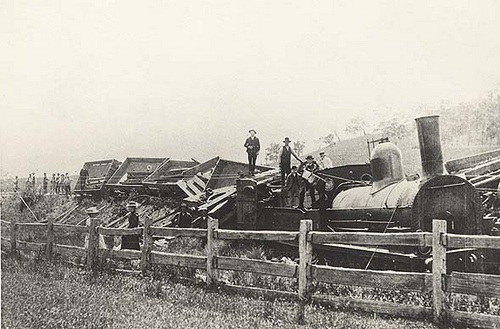Describe the objects in this image and their specific colors. I can see train in ivory, black, gray, darkgray, and lightgray tones, people in ivory, black, gray, darkgray, and lightgray tones, people in ivory, black, and gray tones, people in ivory, gray, black, and darkgray tones, and people in ivory, black, gray, and darkgray tones in this image. 